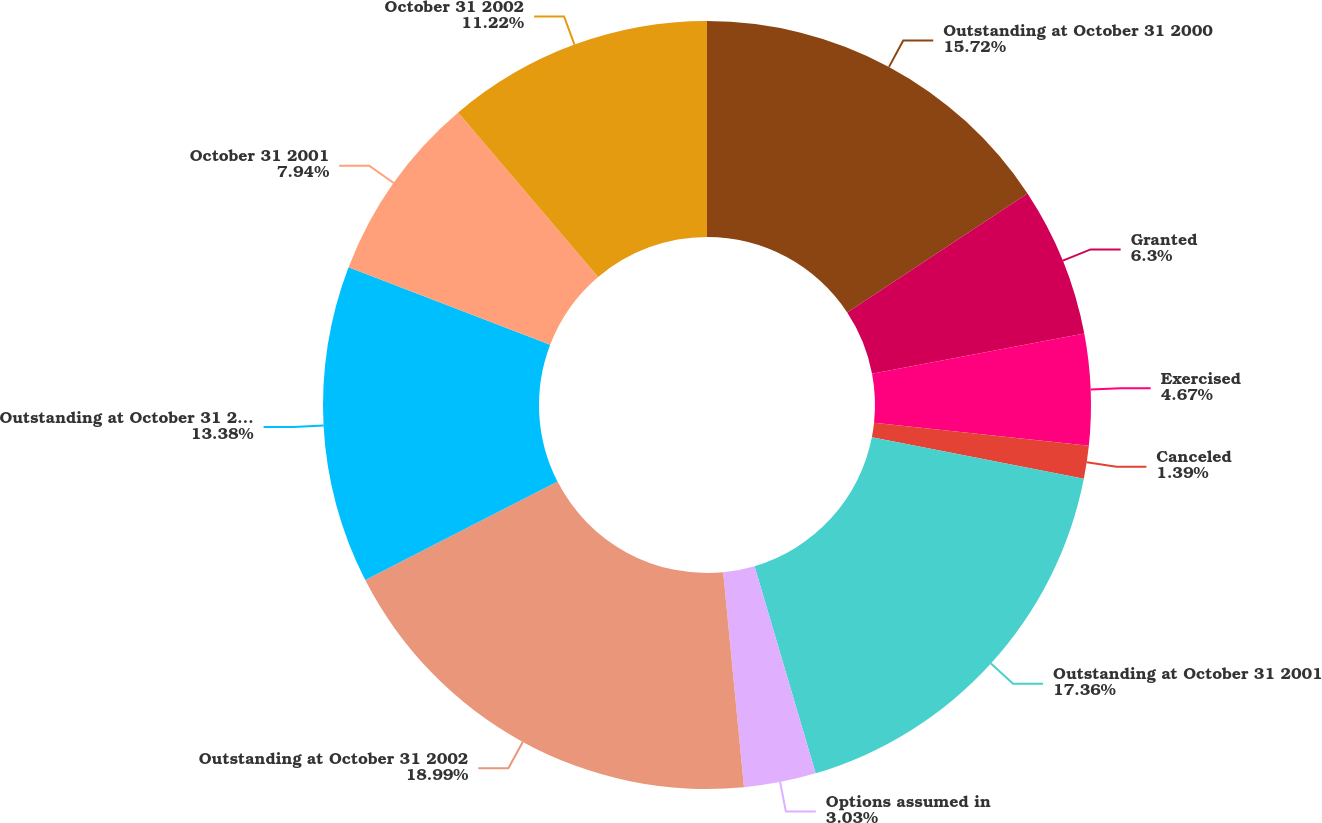<chart> <loc_0><loc_0><loc_500><loc_500><pie_chart><fcel>Outstanding at October 31 2000<fcel>Granted<fcel>Exercised<fcel>Canceled<fcel>Outstanding at October 31 2001<fcel>Options assumed in<fcel>Outstanding at October 31 2002<fcel>Outstanding at October 31 2003<fcel>October 31 2001<fcel>October 31 2002<nl><fcel>15.72%<fcel>6.3%<fcel>4.67%<fcel>1.39%<fcel>17.36%<fcel>3.03%<fcel>19.0%<fcel>13.38%<fcel>7.94%<fcel>11.22%<nl></chart> 